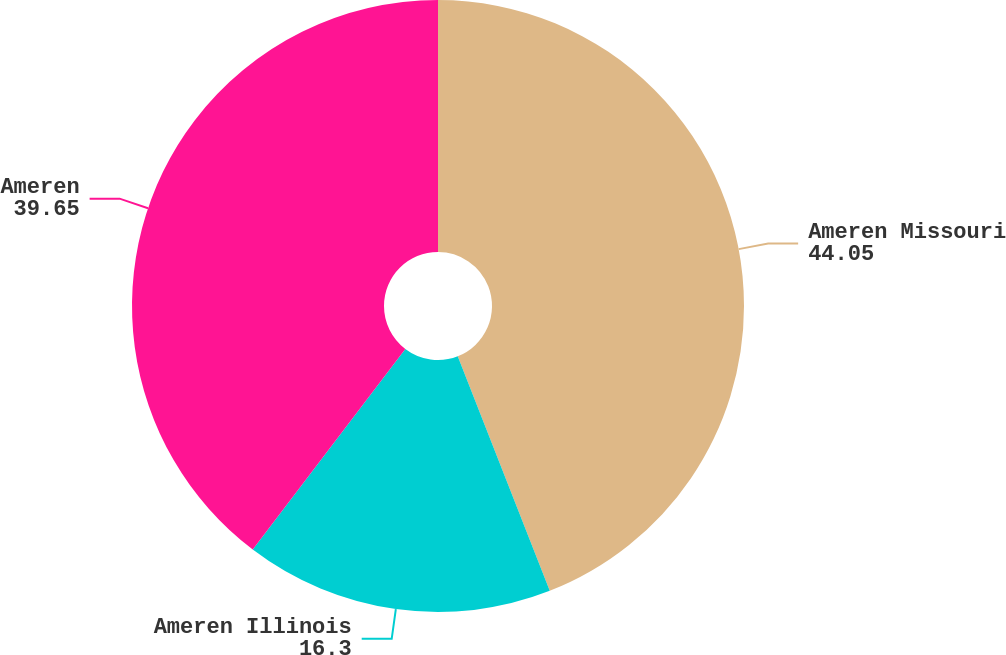<chart> <loc_0><loc_0><loc_500><loc_500><pie_chart><fcel>Ameren Missouri<fcel>Ameren Illinois<fcel>Ameren<nl><fcel>44.05%<fcel>16.3%<fcel>39.65%<nl></chart> 